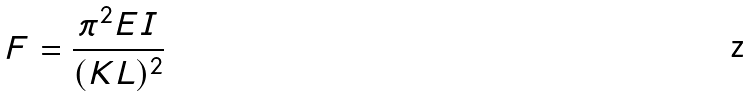<formula> <loc_0><loc_0><loc_500><loc_500>F = { \frac { \pi ^ { 2 } E I } { ( K L ) ^ { 2 } } }</formula> 